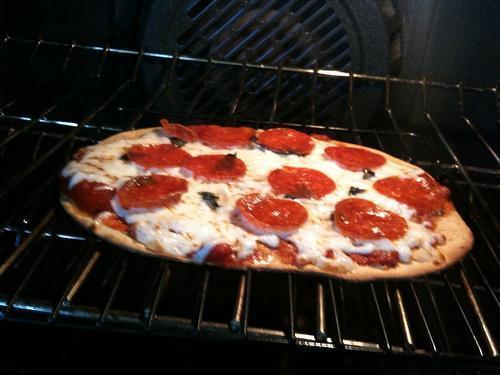Is the caption "The pizza is inside the oven." a true representation of the image?
Answer yes or no. Yes. Verify the accuracy of this image caption: "The oven is beneath the pizza.".
Answer yes or no. No. Evaluate: Does the caption "The oven contains the pizza." match the image?
Answer yes or no. Yes. 